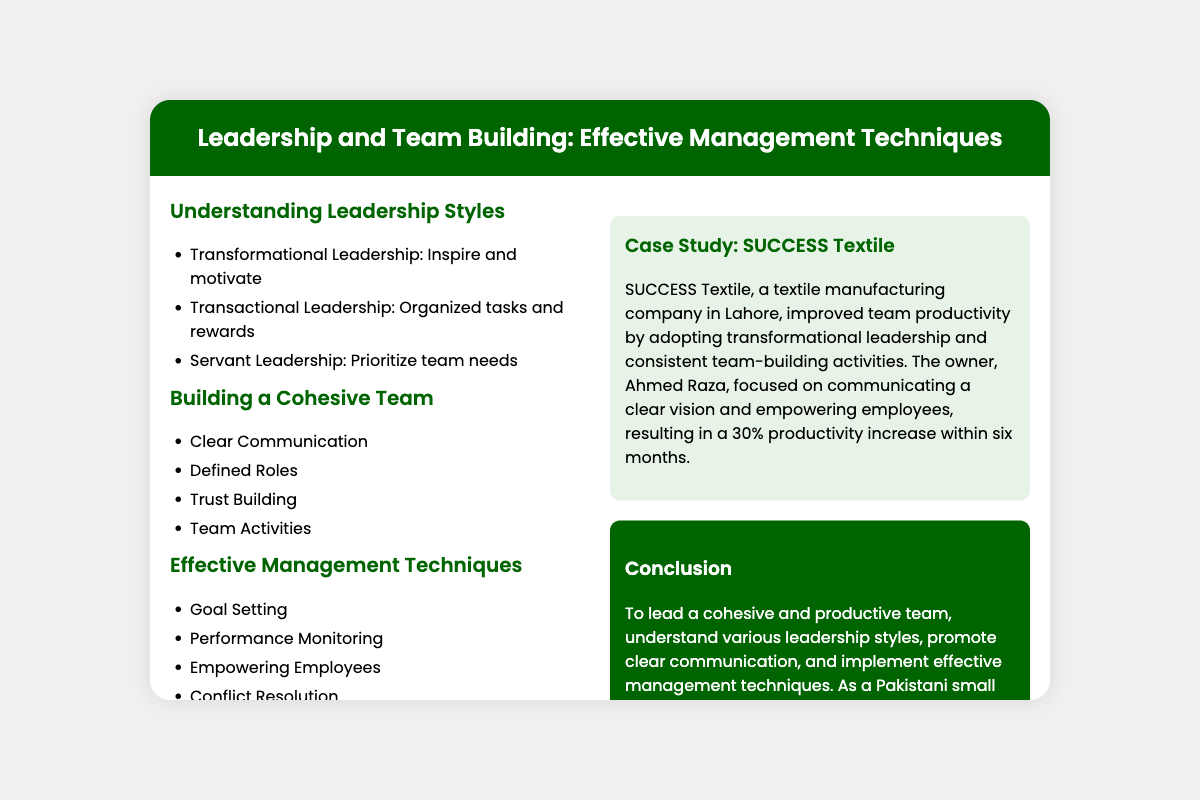what is the title of the presentation? The title of the presentation is displayed prominently at the top of the slide.
Answer: Leadership and Team Building: Effective Management Techniques who is the owner of SUCCESS Textile? The document mentions the owner of SUCCESS Textile in the case study section.
Answer: Ahmed Raza what leadership style focuses on team needs? The document lists various leadership styles under the "Understanding Leadership Styles" section.
Answer: Servant Leadership what percentage did productivity increase at SUCCESS Textile? The case study provides a specific figure related to productivity improvement.
Answer: 30% name one effective management technique mentioned in the document. The content lists several techniques under "Effective Management Techniques."
Answer: Goal Setting what is the background color of the conclusion section? The formatting and design of the conclusion section are detailed in the document.
Answer: Dark green how many leadership styles are mentioned? The document enumerates the different leadership styles listed in the "Understanding Leadership Styles" section.
Answer: Three what is emphasized as necessary for building a cohesive team? The document outlines critical aspects of team building.
Answer: Clear Communication 